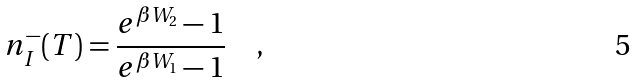<formula> <loc_0><loc_0><loc_500><loc_500>n _ { I } ^ { - } ( T ) = \frac { e ^ { \beta W _ { 2 } } - 1 } { e ^ { \beta W _ { 1 } } - 1 } \quad ,</formula> 